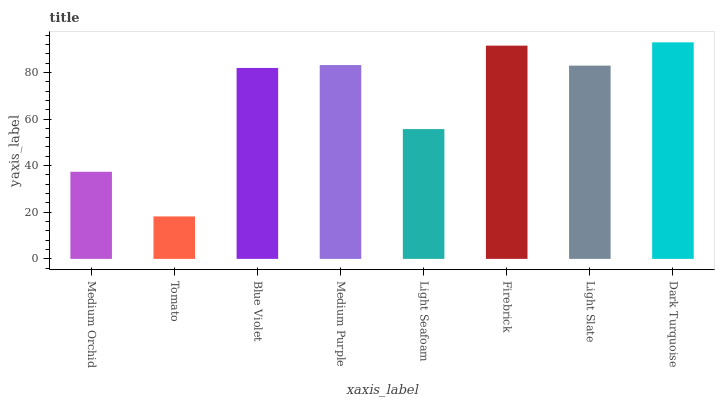Is Tomato the minimum?
Answer yes or no. Yes. Is Dark Turquoise the maximum?
Answer yes or no. Yes. Is Blue Violet the minimum?
Answer yes or no. No. Is Blue Violet the maximum?
Answer yes or no. No. Is Blue Violet greater than Tomato?
Answer yes or no. Yes. Is Tomato less than Blue Violet?
Answer yes or no. Yes. Is Tomato greater than Blue Violet?
Answer yes or no. No. Is Blue Violet less than Tomato?
Answer yes or no. No. Is Light Slate the high median?
Answer yes or no. Yes. Is Blue Violet the low median?
Answer yes or no. Yes. Is Blue Violet the high median?
Answer yes or no. No. Is Firebrick the low median?
Answer yes or no. No. 